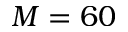Convert formula to latex. <formula><loc_0><loc_0><loc_500><loc_500>M = 6 0</formula> 